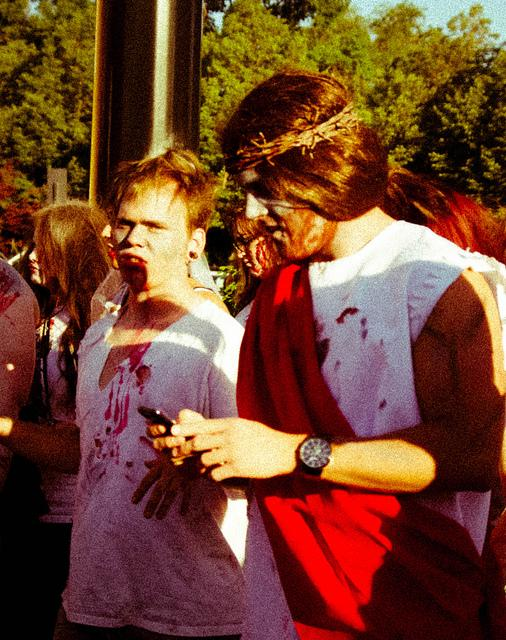What character does the man looking at his cell phone play? jesus 